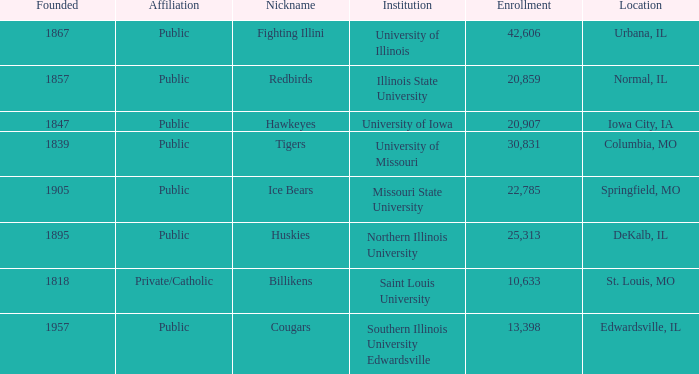What is Southern Illinois University Edwardsville's affiliation? Public. 